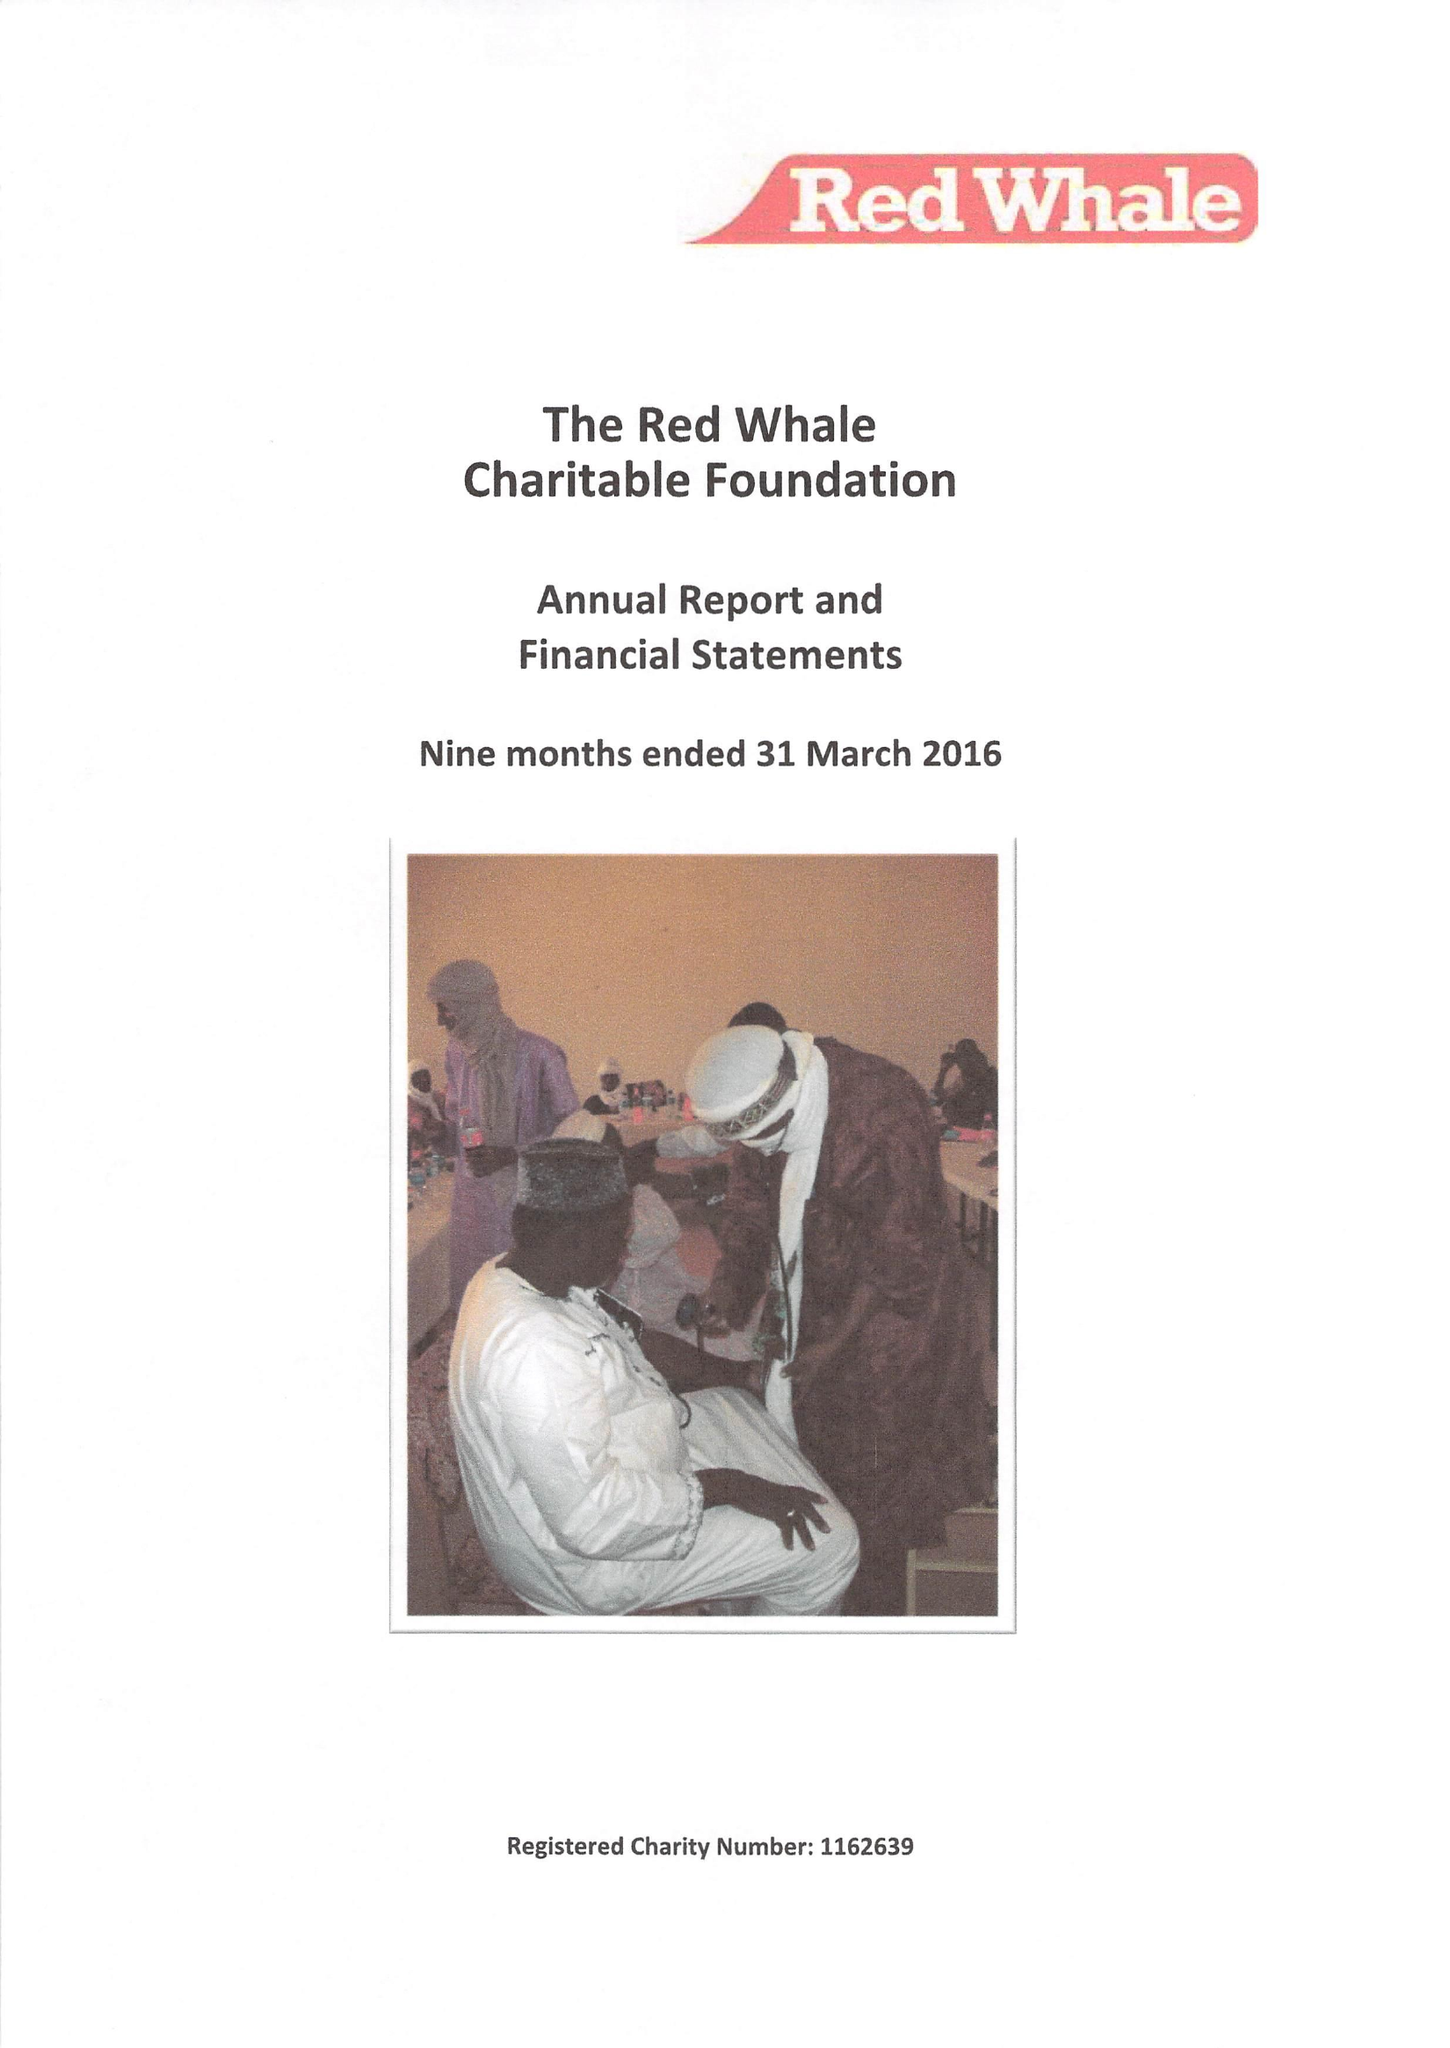What is the value for the income_annually_in_british_pounds?
Answer the question using a single word or phrase. 75000.00 